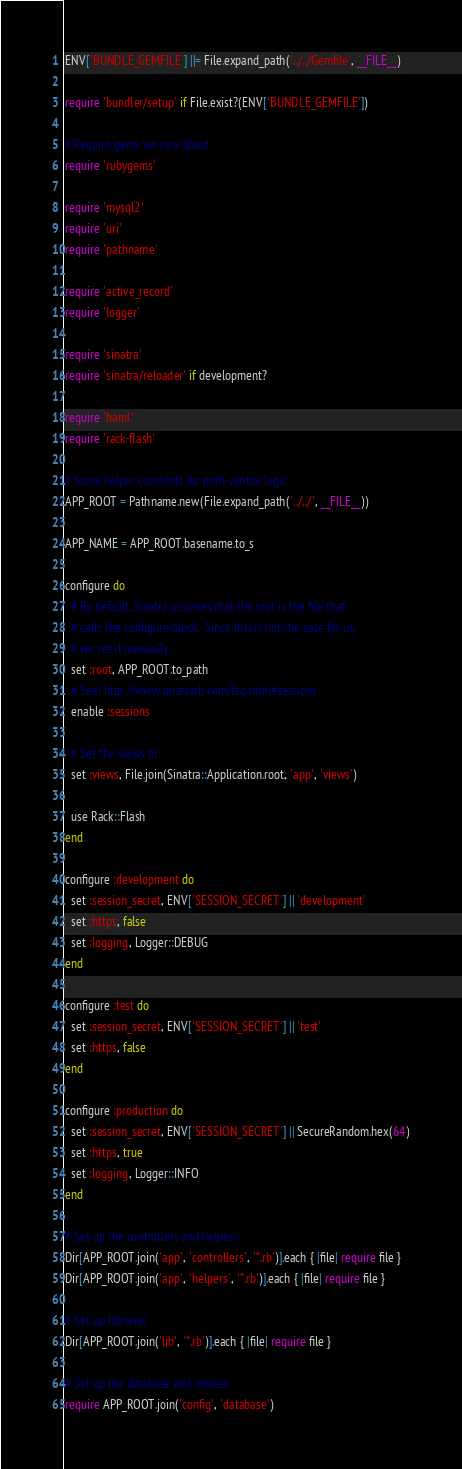<code> <loc_0><loc_0><loc_500><loc_500><_Ruby_>ENV['BUNDLE_GEMFILE'] ||= File.expand_path('../../Gemfile', __FILE__)

require 'bundler/setup' if File.exist?(ENV['BUNDLE_GEMFILE'])

# Require gems we care about
require 'rubygems'

require 'mysql2'
require 'uri'
require 'pathname'

require 'active_record'
require 'logger'

require 'sinatra'
require 'sinatra/reloader' if development?

require 'haml'
require 'rack-flash'

# Some helper constants for path-centric logic
APP_ROOT = Pathname.new(File.expand_path('../../', __FILE__))

APP_NAME = APP_ROOT.basename.to_s

configure do
  # By default, Sinatra assumes that the root is the file that
  # calls the configure block.  Since this is not the case for us,
  # we set it manually.
  set :root, APP_ROOT.to_path
  # See: http://www.sinatrarb.com/faq.html#sessions
  enable :sessions

  # Set the views to
  set :views, File.join(Sinatra::Application.root, 'app', 'views')

  use Rack::Flash
end

configure :development do
  set :session_secret, ENV['SESSION_SECRET'] || 'development'
  set :https, false
  set :logging, Logger::DEBUG
end

configure :test do
  set :session_secret, ENV['SESSION_SECRET'] || 'test'
  set :https, false
end

configure :production do
  set :session_secret, ENV['SESSION_SECRET'] || SecureRandom.hex(64)
  set :https, true
  set :logging, Logger::INFO
end

# Set up the controllers and helpers
Dir[APP_ROOT.join('app', 'controllers', '*.rb')].each { |file| require file }
Dir[APP_ROOT.join('app', 'helpers', '*.rb')].each { |file| require file }

# Set up libraries
Dir[APP_ROOT.join('lib', '*.rb')].each { |file| require file }

# Set up the database and models
require APP_ROOT.join('config', 'database')
</code> 